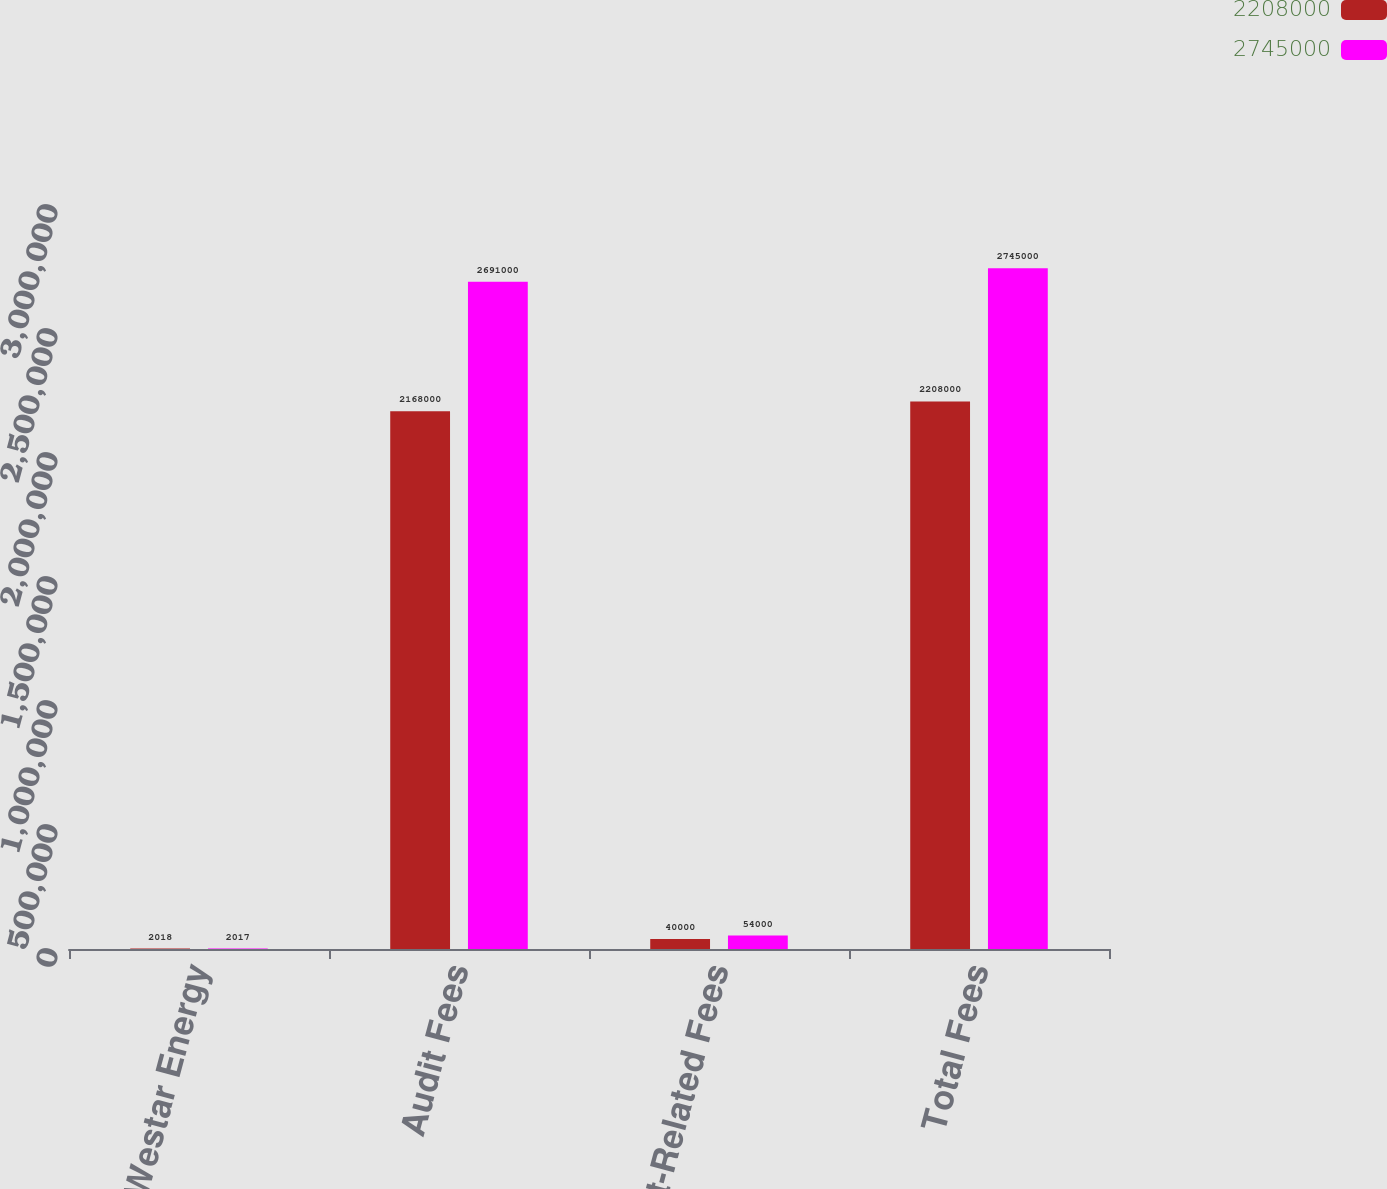Convert chart. <chart><loc_0><loc_0><loc_500><loc_500><stacked_bar_chart><ecel><fcel>Westar Energy<fcel>Audit Fees<fcel>Audit-Related Fees<fcel>Total Fees<nl><fcel>2.208e+06<fcel>2018<fcel>2.168e+06<fcel>40000<fcel>2.208e+06<nl><fcel>2.745e+06<fcel>2017<fcel>2.691e+06<fcel>54000<fcel>2.745e+06<nl></chart> 